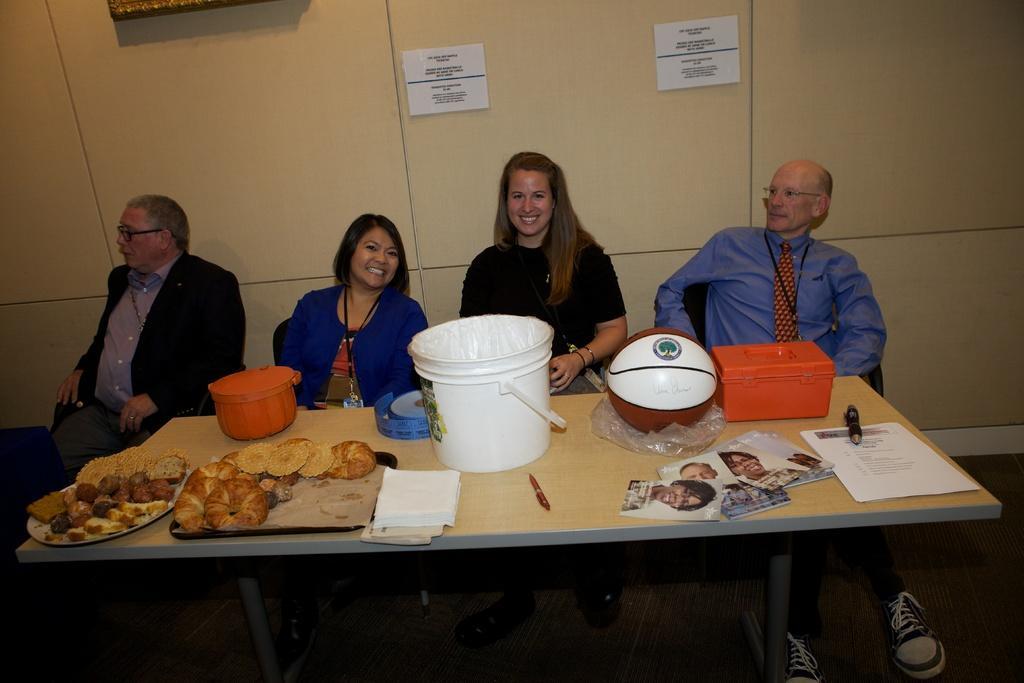How would you summarize this image in a sentence or two? In this image i can see a group of people who are sitting on the chair in front of a table. On the table we have few objects on it. 